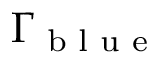Convert formula to latex. <formula><loc_0><loc_0><loc_500><loc_500>\Gamma _ { b l u e }</formula> 